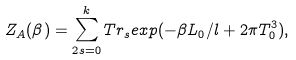Convert formula to latex. <formula><loc_0><loc_0><loc_500><loc_500>Z _ { A } ( \beta ) = \sum _ { 2 s = 0 } ^ { k } T r _ { s } e x p ( - \beta L _ { 0 } / l + 2 \pi T _ { 0 } ^ { 3 } ) ,</formula> 